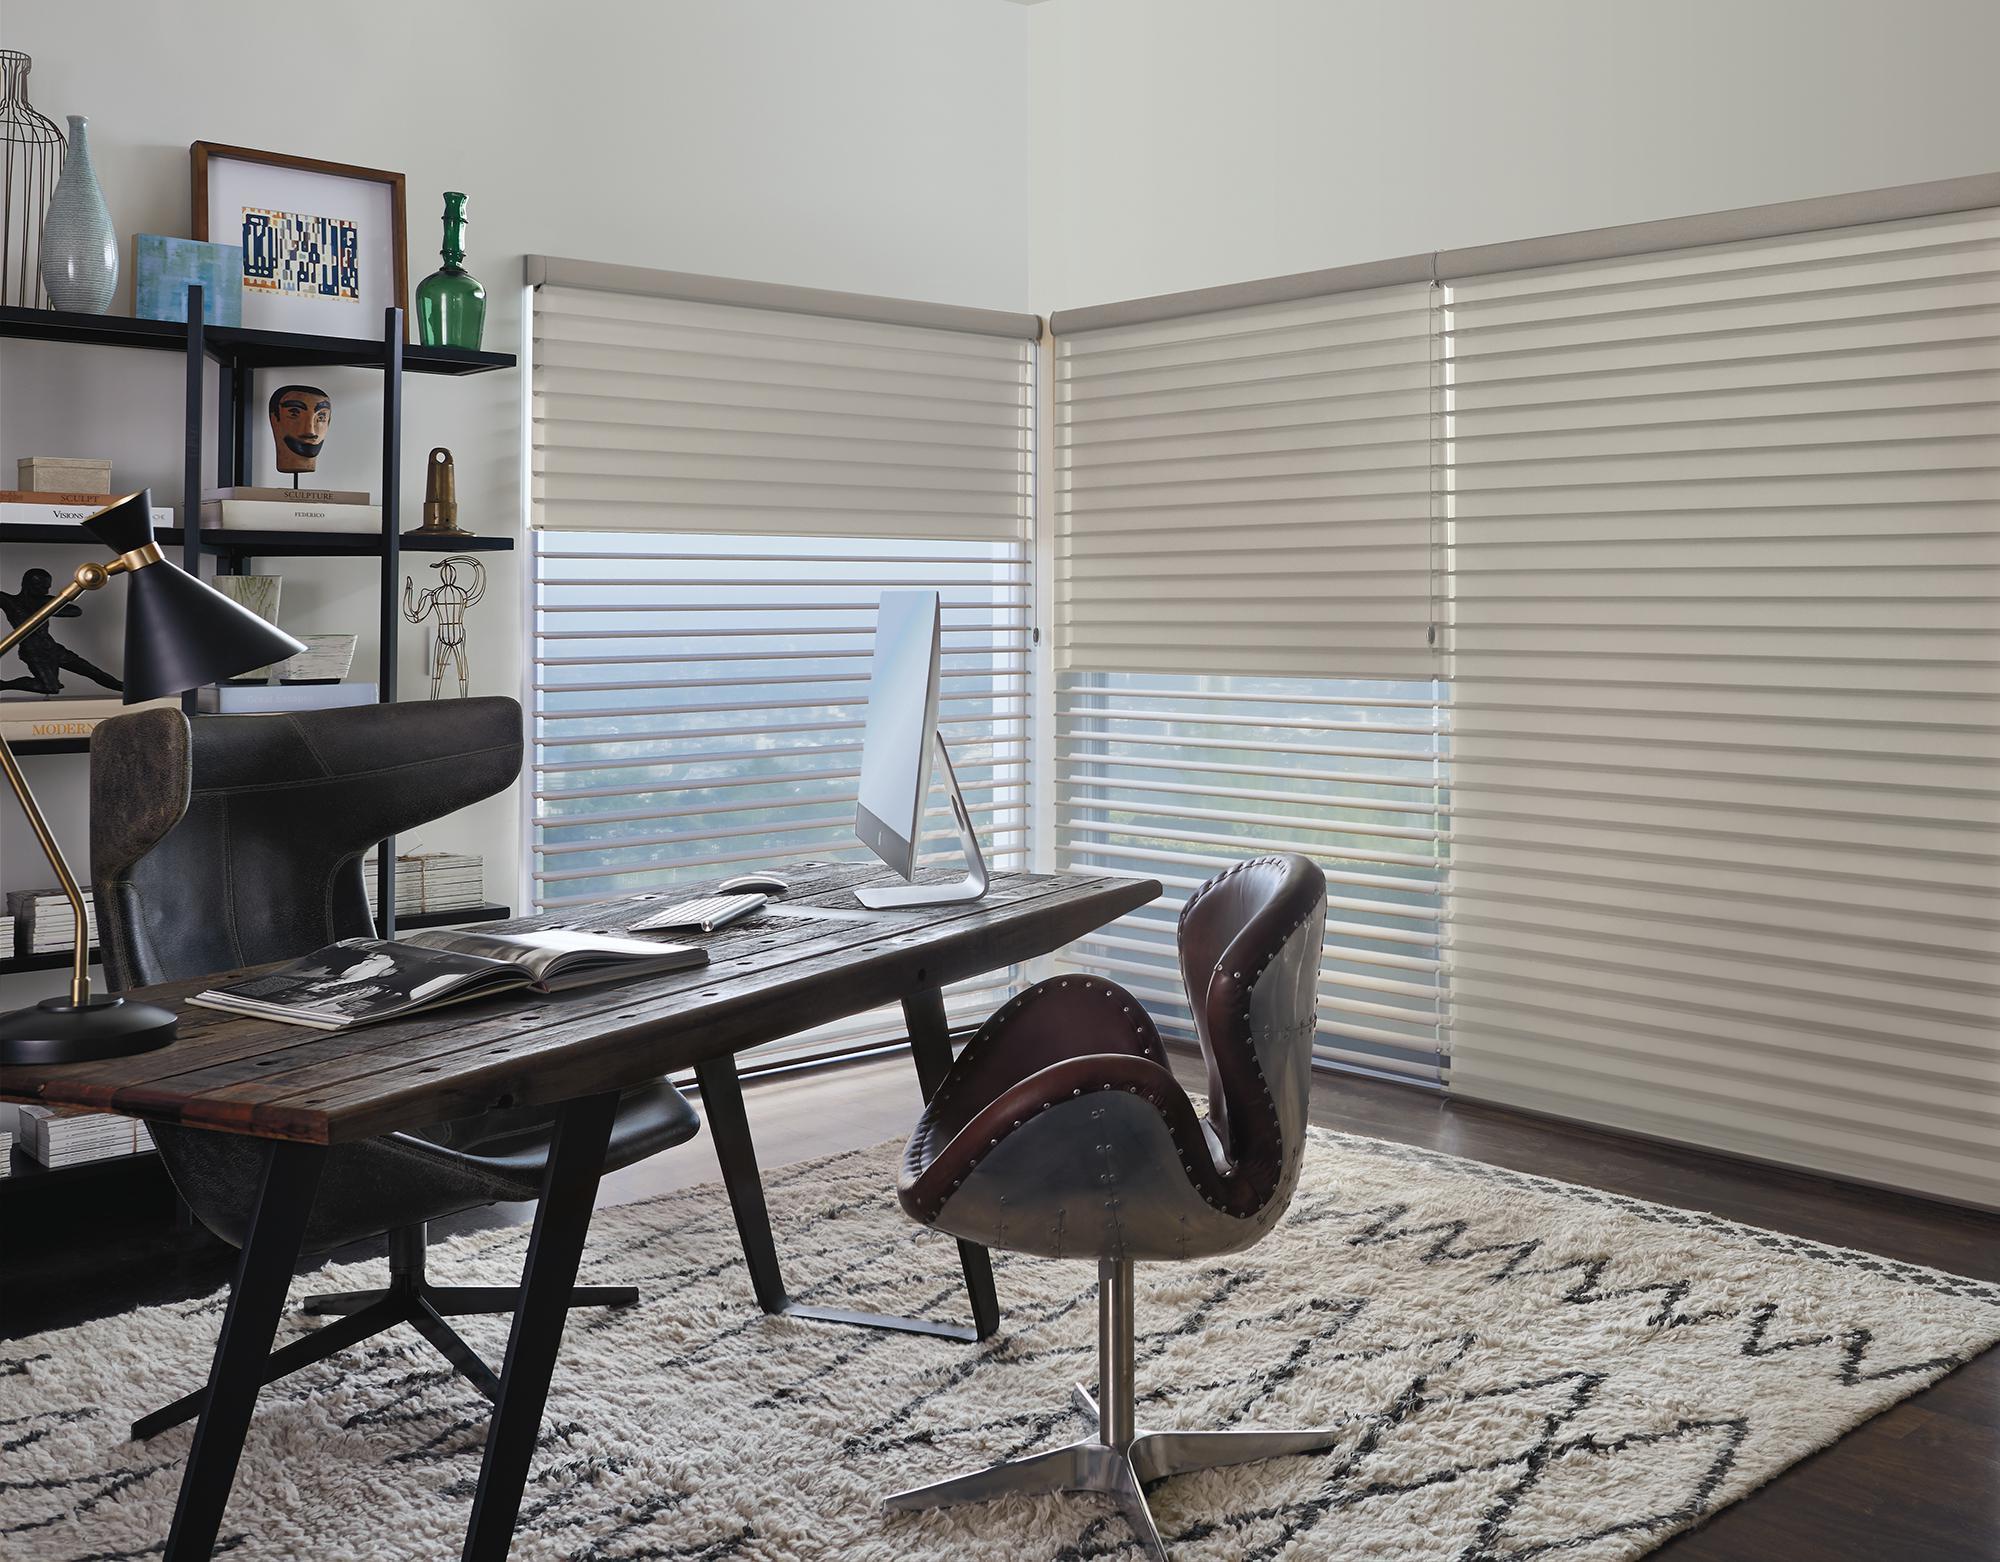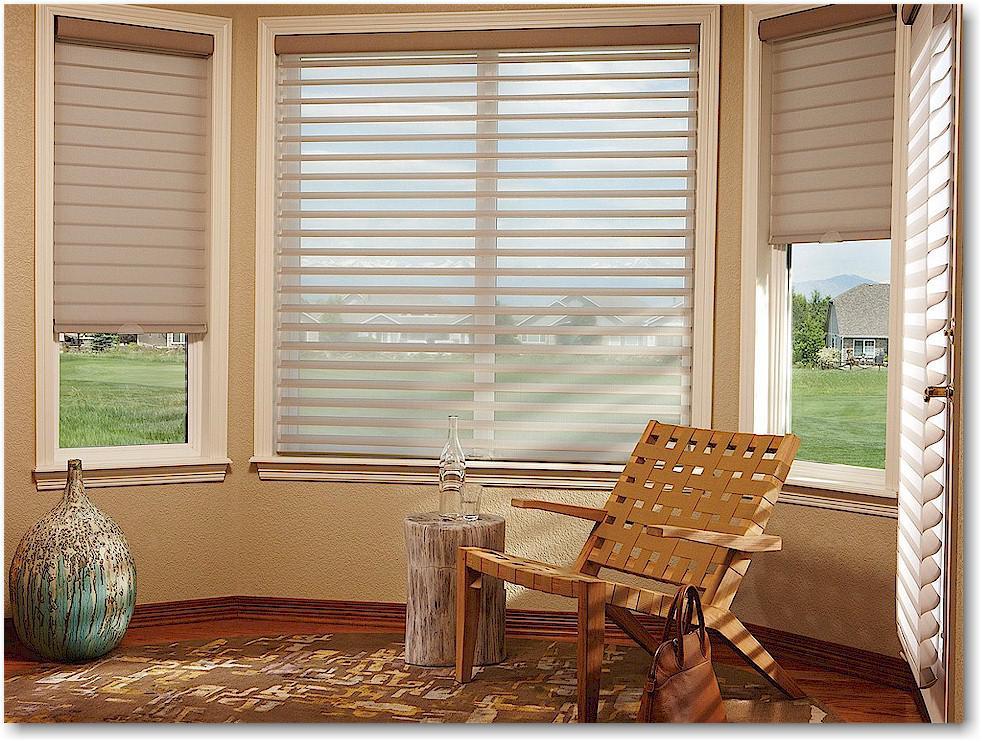The first image is the image on the left, the second image is the image on the right. Considering the images on both sides, is "In at least one image there is a pant on a side table in front of blinds." valid? Answer yes or no. No. 